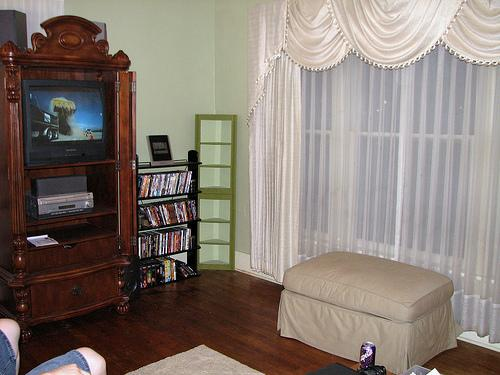Provide a brief description of the dominant objects in the image. A black television, beige ottoman, wooden entertainment center, off-white curtains, soda can on a table, and a rug on the floor. What object(s) in the image is/are used to store DVDs? A dvd movie rack and black shelves that hold dvds. Count the total number of objects that are mentioned in the image. A total of 39 objects are mentioned in the image. What color and type of beverage are in the can placed on the table? Purple and white colored can, containing grape crush soda. Describe the primary furniture present in the room. A beige ottoman, wooden entertainment center, hardwood floor, and a rug in the middle of the room. Analyze the sentiment of the image. What does it convey? The image conveys a cozy and comfortable indoor setting, which evokes a feeling of relaxation and leisure time. Mention one unusual item present in the room. A green empty rack in the corner of the room might be considered as an unusual item. How many instances of the can on the table are mentioned in the image, and what are their descriptions? There are 10 instances of the can, described as purple, aluminum, on the table, on the corner, and as Grape Crush soda. What items are related to entertainment in this image? Television, wooden entertainment center, shelf for games and movies, and the DVD player. Who or what is interacting with the television in this image? There are legs of a person who might be watching the television. How is the wooden floor described in the image? Brown shiny hardwood Can you identify any orange couch positioned near the entertainment center and tell me its brand name? In the provided information, there is nothing about an orange couch or any couch for that matter. The instruction asks to identify the couch (interrogative part) and then provide the brand name (declarative part) of a non-existent object in the image. Which objects are part of the entertainment center in the image? TV, DVD player, shelves for DVDs Which of the following objects is on the corner of the table? A) Grape Crush Soda Can B) DVD player C) Ottoman D) Television A) Grape Crush Soda Can Create a scene depicting the objects and activities described in the given image. Living room scene with TV, beige ottoman, wooden entertainment center, off white drapes, purple soda can on table, and person watching TV List the furniture items seen in the image. Television, ottoman, entertainment center, table, DVD player, shelves What color is the television in the image? Black Look for a small red table clock on the wooden entertainment center, and state whether it's digital or analog. The image has no information about a red table clock, so it's a non-existent object. The instruction asks the reader to look for the clock (interrogative part) and then provide information of whether it's digital or analog (declarative part). Explain the appearance of the entertainment center in the room. Wooden entertainment center with a black television and shelves for dvds What object can be found on the table? Purple and white can of soda (Grape Crush Soda) Could you point out the yellow decorative pillow on the beige ottoman and share your opinion on its design? No, it's not mentioned in the image. What kind of shelf is the green empty rack? Corner plant stand Describe the style of the curtains in the image. Off white colored drapes Find a potted plant near the green empty rack and let me know if the leaves are real or artificial. The provided image information does not include a potted plant. This instruction involves finding the potted plant (interrogative part) and assessing the details of the leaves (declarative part) of a non-existent object. Can you find any objects related to Netflix in the image? Yes, a Netflix rental What activity is happening during this event? Someone is watching TV What kind of beverage is in the purple and white can of soda? Grape Crush Soda Is the entertainment center capable of holding a television and DVDs? Yes / No Yes Describe the layout of the room in the image. Living room with a wooden entertainment center, a television, off white colored drapes, beige ottoman, table with purple soda can, and person watching TV What does the person seem to be doing in this photo? Watching TV; only the legs can be seen. With reference to the image, provide a description for the ottoman. A large beige colored ottoman on the floor Create an image featuring distinct objects and activities depicted in this text. An image of a living room with TV, ottoman, grape crush soda can on table, and person watching TV 